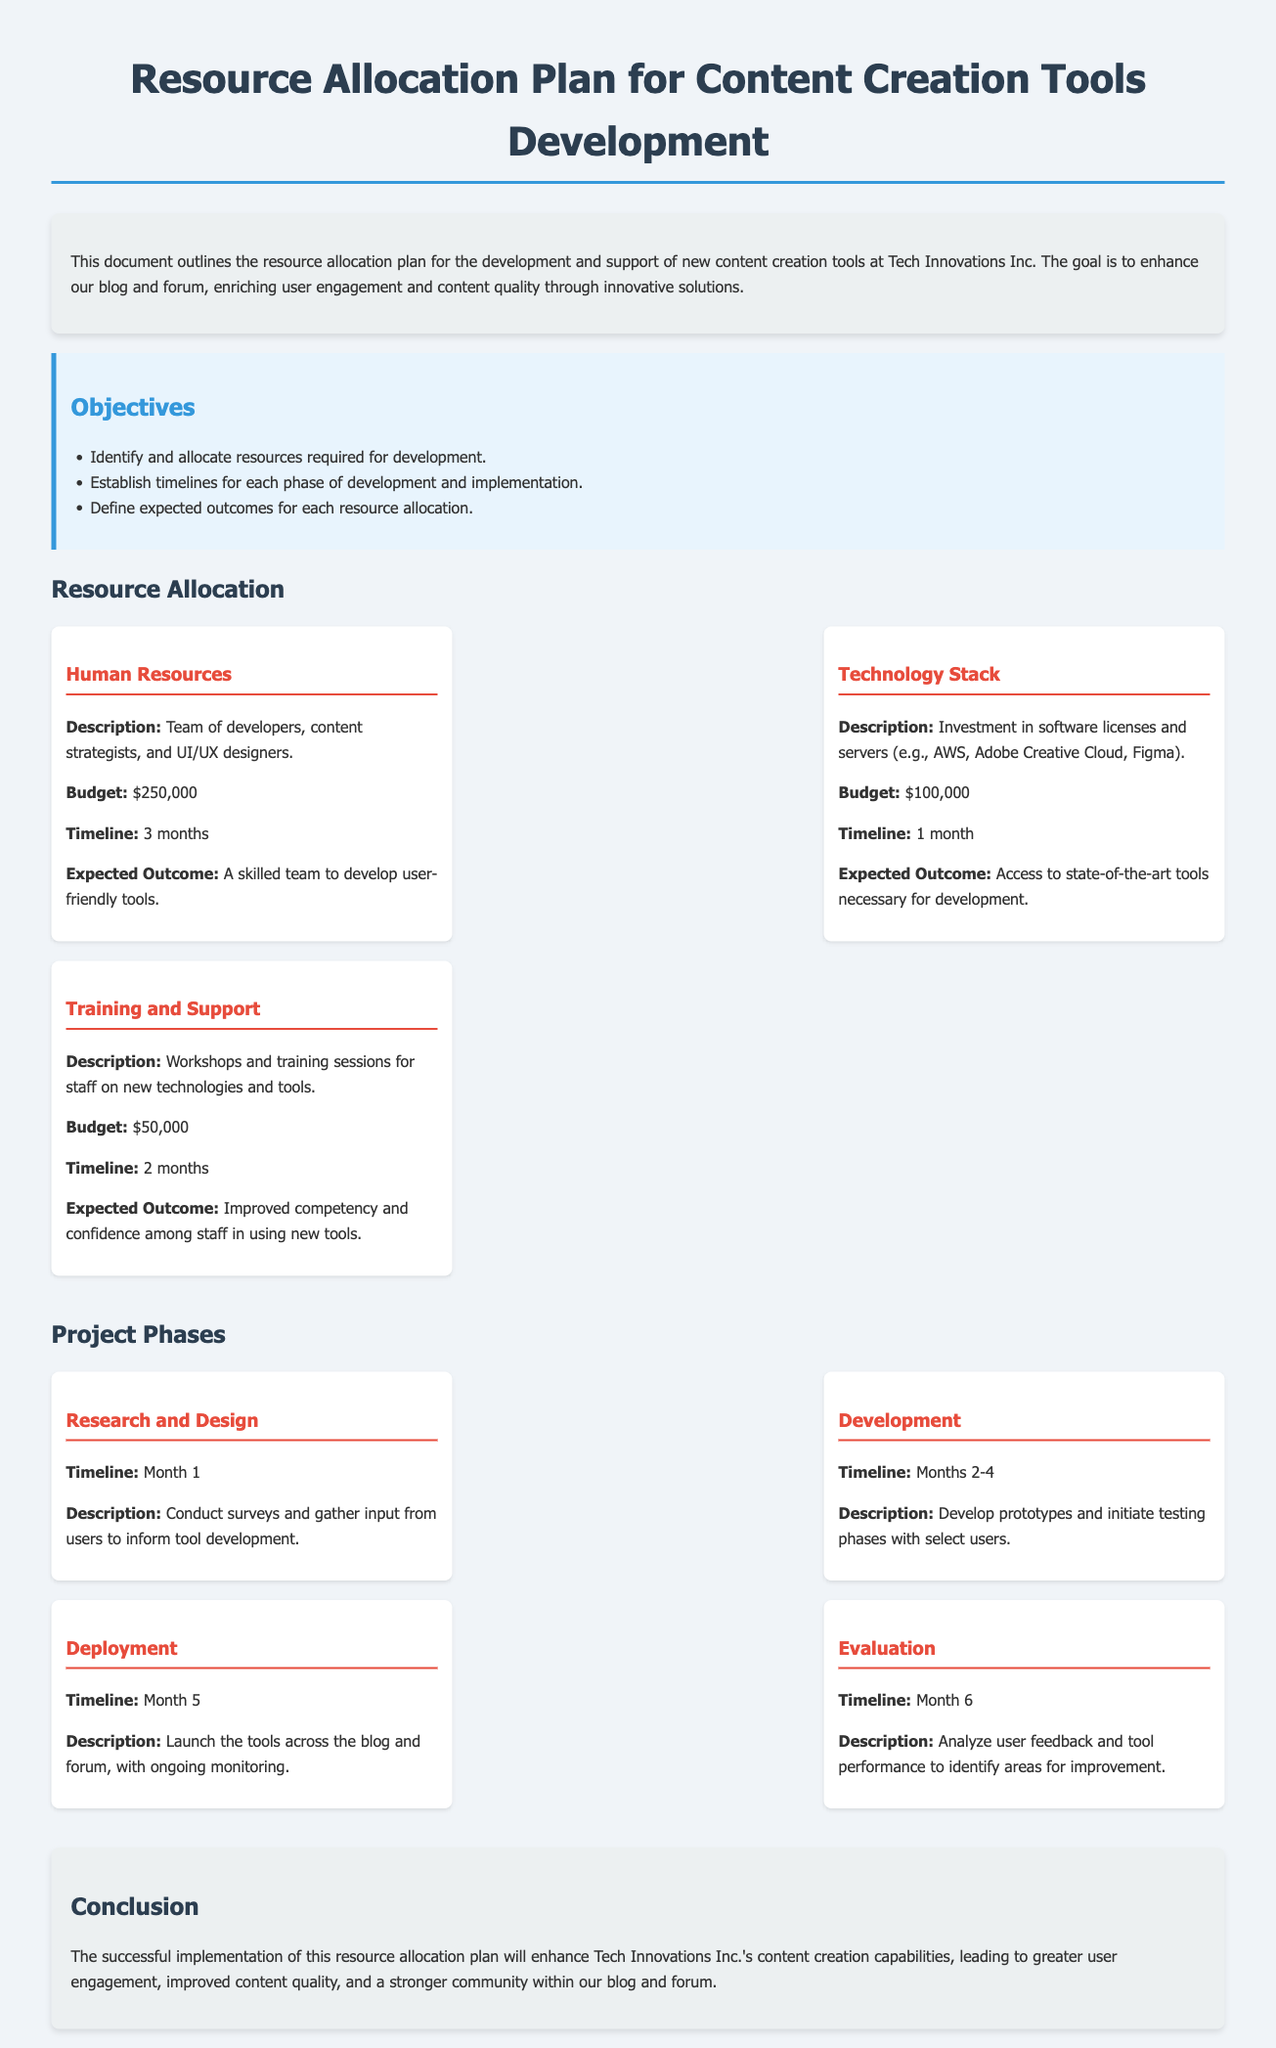what is the total budget for Human Resources? The budget for Human Resources is given in the resource allocation section of the document.
Answer: $250,000 what is the timeline for the Technology Stack resource? The timeline is specified under the Technology Stack section in the document.
Answer: 1 month how many phases are outlined in the project phases? The number of phases can be found by counting each phase listed in the project phases section.
Answer: 4 what is the expected outcome for Training and Support? The expected outcome is detailed in the Training and Support section of the document.
Answer: Improved competency and confidence among staff in using new tools what is the primary goal of the resource allocation plan? The primary goal is outlined in the introductory paragraph of the document.
Answer: Enhance our blog and forum what phase involves conducting surveys? The phase associated with conducting surveys is mentioned in the project phases section.
Answer: Research and Design who is responsible for the training workshops? The document specifies that training workshops are for staff, indicating who benefits from them.
Answer: Staff what month is designated for the Evaluation phase? The month for the Evaluation phase is clearly indicated in the project phases section.
Answer: Month 6 